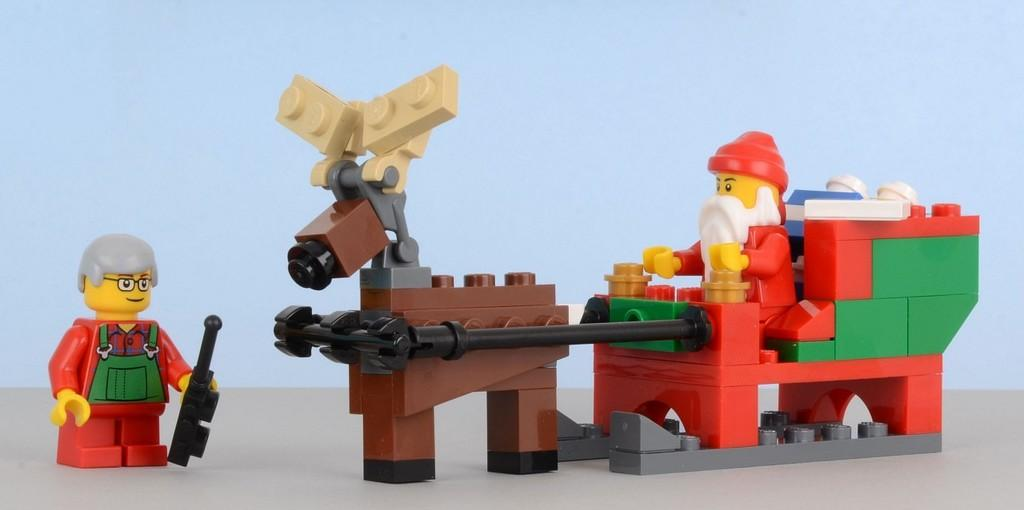What objects are in the center of the image? There are building blocks and toys in the center of the image. What can be seen in the background of the image? There is a wall in the background of the image. What direction is the yak facing in the image? There is no yak present in the image. What type of bait is being used to catch fish in the image? There is no fishing or bait present in the image. 